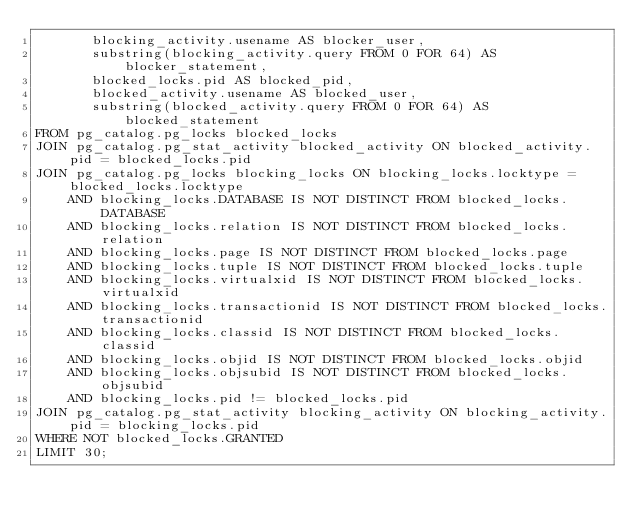<code> <loc_0><loc_0><loc_500><loc_500><_SQL_>       blocking_activity.usename AS blocker_user,
       substring(blocking_activity.query FROM 0 FOR 64) AS blocker_statement,
       blocked_locks.pid AS blocked_pid,
       blocked_activity.usename AS blocked_user,
       substring(blocked_activity.query FROM 0 FOR 64) AS blocked_statement
FROM pg_catalog.pg_locks blocked_locks
JOIN pg_catalog.pg_stat_activity blocked_activity ON blocked_activity.pid = blocked_locks.pid
JOIN pg_catalog.pg_locks blocking_locks ON blocking_locks.locktype = blocked_locks.locktype
    AND blocking_locks.DATABASE IS NOT DISTINCT FROM blocked_locks.DATABASE
    AND blocking_locks.relation IS NOT DISTINCT FROM blocked_locks.relation
    AND blocking_locks.page IS NOT DISTINCT FROM blocked_locks.page
    AND blocking_locks.tuple IS NOT DISTINCT FROM blocked_locks.tuple
    AND blocking_locks.virtualxid IS NOT DISTINCT FROM blocked_locks.virtualxid
    AND blocking_locks.transactionid IS NOT DISTINCT FROM blocked_locks.transactionid
    AND blocking_locks.classid IS NOT DISTINCT FROM blocked_locks.classid
    AND blocking_locks.objid IS NOT DISTINCT FROM blocked_locks.objid
    AND blocking_locks.objsubid IS NOT DISTINCT FROM blocked_locks.objsubid
    AND blocking_locks.pid != blocked_locks.pid
JOIN pg_catalog.pg_stat_activity blocking_activity ON blocking_activity.pid = blocking_locks.pid
WHERE NOT blocked_locks.GRANTED
LIMIT 30;</code> 